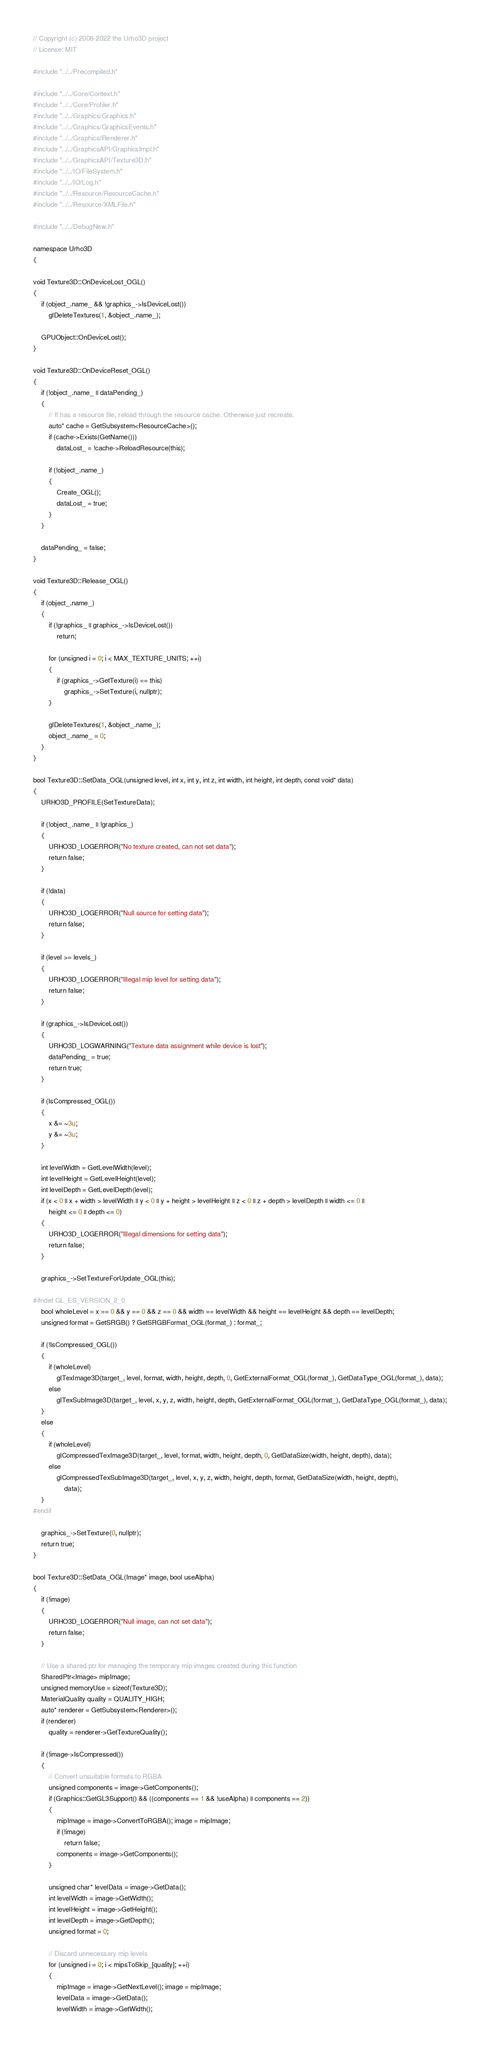<code> <loc_0><loc_0><loc_500><loc_500><_C++_>// Copyright (c) 2008-2022 the Urho3D project
// License: MIT

#include "../../Precompiled.h"

#include "../../Core/Context.h"
#include "../../Core/Profiler.h"
#include "../../Graphics/Graphics.h"
#include "../../Graphics/GraphicsEvents.h"
#include "../../Graphics/Renderer.h"
#include "../../GraphicsAPI/GraphicsImpl.h"
#include "../../GraphicsAPI/Texture3D.h"
#include "../../IO/FileSystem.h"
#include "../../IO/Log.h"
#include "../../Resource/ResourceCache.h"
#include "../../Resource/XMLFile.h"

#include "../../DebugNew.h"

namespace Urho3D
{

void Texture3D::OnDeviceLost_OGL()
{
    if (object_.name_ && !graphics_->IsDeviceLost())
        glDeleteTextures(1, &object_.name_);

    GPUObject::OnDeviceLost();
}

void Texture3D::OnDeviceReset_OGL()
{
    if (!object_.name_ || dataPending_)
    {
        // If has a resource file, reload through the resource cache. Otherwise just recreate.
        auto* cache = GetSubsystem<ResourceCache>();
        if (cache->Exists(GetName()))
            dataLost_ = !cache->ReloadResource(this);

        if (!object_.name_)
        {
            Create_OGL();
            dataLost_ = true;
        }
    }

    dataPending_ = false;
}

void Texture3D::Release_OGL()
{
    if (object_.name_)
    {
        if (!graphics_ || graphics_->IsDeviceLost())
            return;

        for (unsigned i = 0; i < MAX_TEXTURE_UNITS; ++i)
        {
            if (graphics_->GetTexture(i) == this)
                graphics_->SetTexture(i, nullptr);
        }

        glDeleteTextures(1, &object_.name_);
        object_.name_ = 0;
    }
}

bool Texture3D::SetData_OGL(unsigned level, int x, int y, int z, int width, int height, int depth, const void* data)
{
    URHO3D_PROFILE(SetTextureData);

    if (!object_.name_ || !graphics_)
    {
        URHO3D_LOGERROR("No texture created, can not set data");
        return false;
    }

    if (!data)
    {
        URHO3D_LOGERROR("Null source for setting data");
        return false;
    }

    if (level >= levels_)
    {
        URHO3D_LOGERROR("Illegal mip level for setting data");
        return false;
    }

    if (graphics_->IsDeviceLost())
    {
        URHO3D_LOGWARNING("Texture data assignment while device is lost");
        dataPending_ = true;
        return true;
    }

    if (IsCompressed_OGL())
    {
        x &= ~3u;
        y &= ~3u;
    }

    int levelWidth = GetLevelWidth(level);
    int levelHeight = GetLevelHeight(level);
    int levelDepth = GetLevelDepth(level);
    if (x < 0 || x + width > levelWidth || y < 0 || y + height > levelHeight || z < 0 || z + depth > levelDepth || width <= 0 ||
        height <= 0 || depth <= 0)
    {
        URHO3D_LOGERROR("Illegal dimensions for setting data");
        return false;
    }

    graphics_->SetTextureForUpdate_OGL(this);

#ifndef GL_ES_VERSION_2_0
    bool wholeLevel = x == 0 && y == 0 && z == 0 && width == levelWidth && height == levelHeight && depth == levelDepth;
    unsigned format = GetSRGB() ? GetSRGBFormat_OGL(format_) : format_;

    if (!IsCompressed_OGL())
    {
        if (wholeLevel)
            glTexImage3D(target_, level, format, width, height, depth, 0, GetExternalFormat_OGL(format_), GetDataType_OGL(format_), data);
        else
            glTexSubImage3D(target_, level, x, y, z, width, height, depth, GetExternalFormat_OGL(format_), GetDataType_OGL(format_), data);
    }
    else
    {
        if (wholeLevel)
            glCompressedTexImage3D(target_, level, format, width, height, depth, 0, GetDataSize(width, height, depth), data);
        else
            glCompressedTexSubImage3D(target_, level, x, y, z, width, height, depth, format, GetDataSize(width, height, depth),
                data);
    }
#endif

    graphics_->SetTexture(0, nullptr);
    return true;
}

bool Texture3D::SetData_OGL(Image* image, bool useAlpha)
{
    if (!image)
    {
        URHO3D_LOGERROR("Null image, can not set data");
        return false;
    }

    // Use a shared ptr for managing the temporary mip images created during this function
    SharedPtr<Image> mipImage;
    unsigned memoryUse = sizeof(Texture3D);
    MaterialQuality quality = QUALITY_HIGH;
    auto* renderer = GetSubsystem<Renderer>();
    if (renderer)
        quality = renderer->GetTextureQuality();

    if (!image->IsCompressed())
    {
        // Convert unsuitable formats to RGBA
        unsigned components = image->GetComponents();
        if (Graphics::GetGL3Support() && ((components == 1 && !useAlpha) || components == 2))
        {
            mipImage = image->ConvertToRGBA(); image = mipImage;
            if (!image)
                return false;
            components = image->GetComponents();
        }

        unsigned char* levelData = image->GetData();
        int levelWidth = image->GetWidth();
        int levelHeight = image->GetHeight();
        int levelDepth = image->GetDepth();
        unsigned format = 0;

        // Discard unnecessary mip levels
        for (unsigned i = 0; i < mipsToSkip_[quality]; ++i)
        {
            mipImage = image->GetNextLevel(); image = mipImage;
            levelData = image->GetData();
            levelWidth = image->GetWidth();</code> 